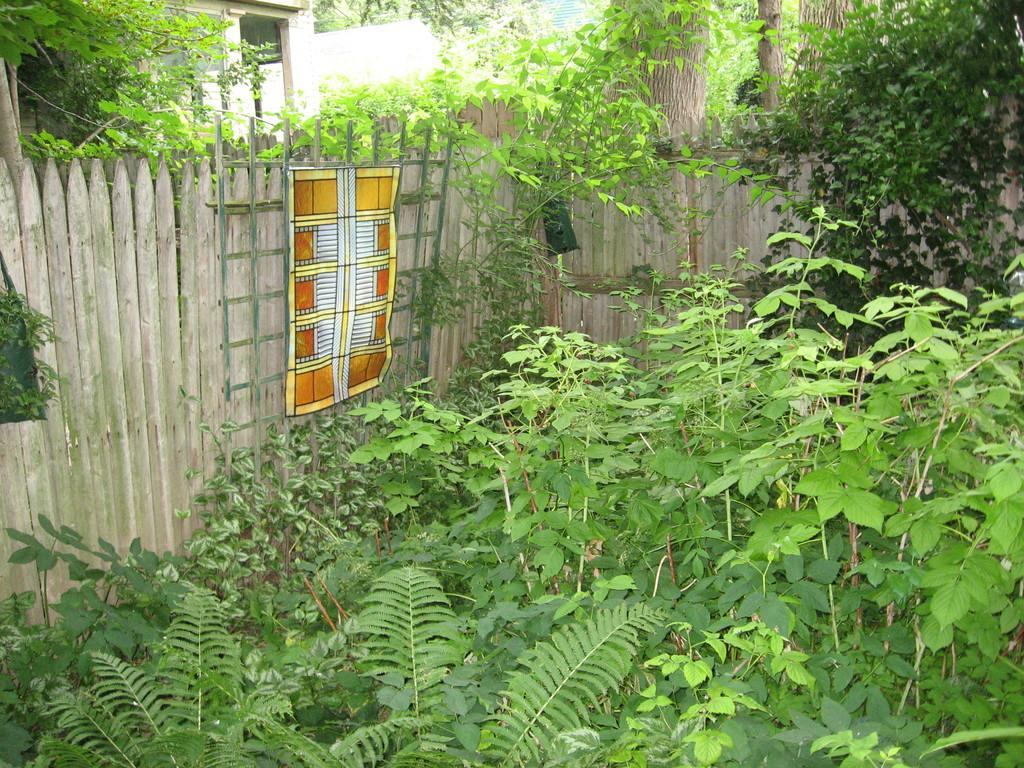What type of living organisms can be seen in the image? Plants and trees are visible in the image. What type of structure can be seen in the image? There is a wooden fence in the image. Where are the chickens kept in the image? There are no chickens present in the image. What type of oil can be seen dripping from the trees in the image? There is no oil present in the image; it features plants, trees, and a wooden fence. 